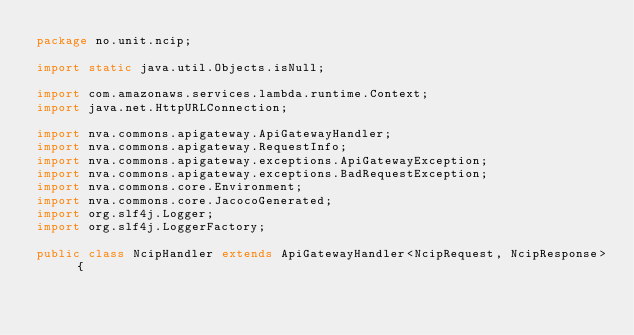<code> <loc_0><loc_0><loc_500><loc_500><_Java_>package no.unit.ncip;

import static java.util.Objects.isNull;

import com.amazonaws.services.lambda.runtime.Context;
import java.net.HttpURLConnection;

import nva.commons.apigateway.ApiGatewayHandler;
import nva.commons.apigateway.RequestInfo;
import nva.commons.apigateway.exceptions.ApiGatewayException;
import nva.commons.apigateway.exceptions.BadRequestException;
import nva.commons.core.Environment;
import nva.commons.core.JacocoGenerated;
import org.slf4j.Logger;
import org.slf4j.LoggerFactory;

public class NcipHandler extends ApiGatewayHandler<NcipRequest, NcipResponse> {
</code> 